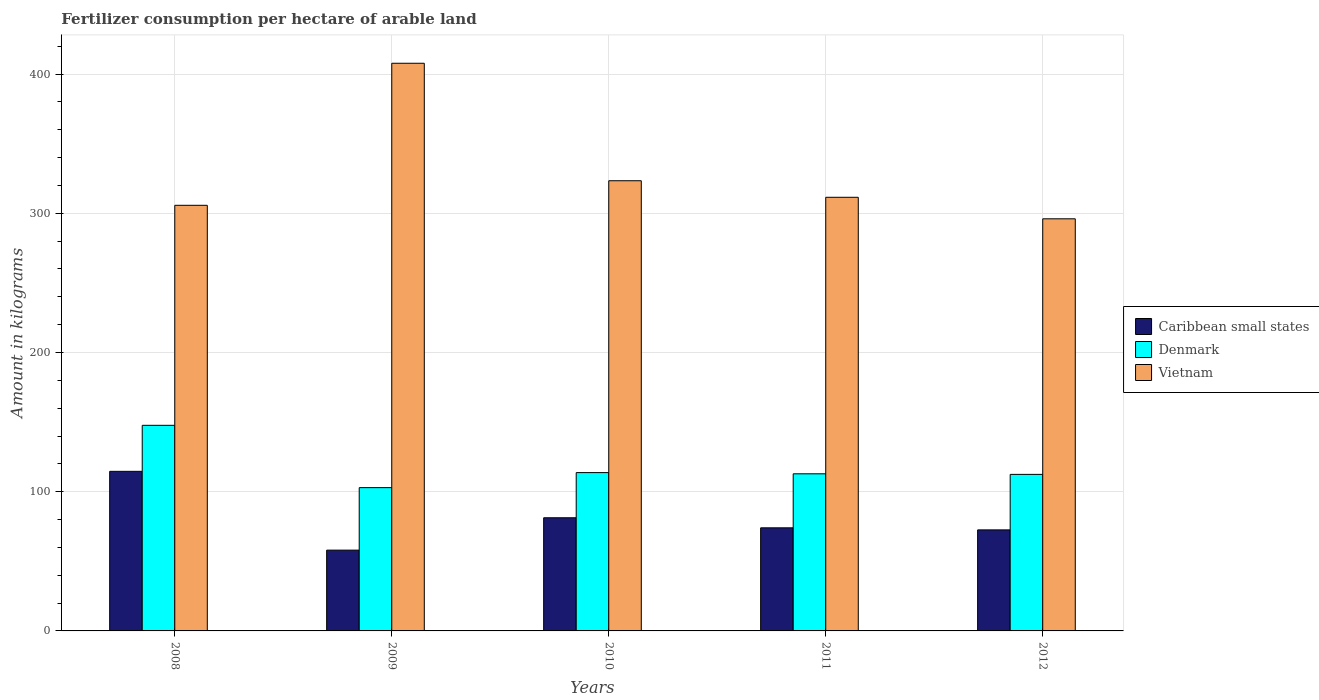Are the number of bars per tick equal to the number of legend labels?
Your response must be concise. Yes. Are the number of bars on each tick of the X-axis equal?
Provide a succinct answer. Yes. How many bars are there on the 1st tick from the left?
Give a very brief answer. 3. How many bars are there on the 3rd tick from the right?
Your answer should be compact. 3. In how many cases, is the number of bars for a given year not equal to the number of legend labels?
Provide a short and direct response. 0. What is the amount of fertilizer consumption in Denmark in 2009?
Provide a succinct answer. 102.92. Across all years, what is the maximum amount of fertilizer consumption in Vietnam?
Keep it short and to the point. 407.72. Across all years, what is the minimum amount of fertilizer consumption in Denmark?
Ensure brevity in your answer.  102.92. In which year was the amount of fertilizer consumption in Vietnam minimum?
Your answer should be very brief. 2012. What is the total amount of fertilizer consumption in Denmark in the graph?
Give a very brief answer. 589.59. What is the difference between the amount of fertilizer consumption in Caribbean small states in 2011 and that in 2012?
Provide a succinct answer. 1.49. What is the difference between the amount of fertilizer consumption in Vietnam in 2008 and the amount of fertilizer consumption in Caribbean small states in 2010?
Keep it short and to the point. 224.42. What is the average amount of fertilizer consumption in Caribbean small states per year?
Provide a succinct answer. 80.11. In the year 2011, what is the difference between the amount of fertilizer consumption in Denmark and amount of fertilizer consumption in Caribbean small states?
Provide a short and direct response. 38.79. In how many years, is the amount of fertilizer consumption in Caribbean small states greater than 400 kg?
Make the answer very short. 0. What is the ratio of the amount of fertilizer consumption in Denmark in 2009 to that in 2012?
Provide a short and direct response. 0.92. Is the difference between the amount of fertilizer consumption in Denmark in 2009 and 2010 greater than the difference between the amount of fertilizer consumption in Caribbean small states in 2009 and 2010?
Give a very brief answer. Yes. What is the difference between the highest and the second highest amount of fertilizer consumption in Caribbean small states?
Your response must be concise. 33.34. What is the difference between the highest and the lowest amount of fertilizer consumption in Caribbean small states?
Give a very brief answer. 56.59. In how many years, is the amount of fertilizer consumption in Denmark greater than the average amount of fertilizer consumption in Denmark taken over all years?
Make the answer very short. 1. Is the sum of the amount of fertilizer consumption in Denmark in 2008 and 2011 greater than the maximum amount of fertilizer consumption in Vietnam across all years?
Provide a succinct answer. No. Is it the case that in every year, the sum of the amount of fertilizer consumption in Denmark and amount of fertilizer consumption in Caribbean small states is greater than the amount of fertilizer consumption in Vietnam?
Keep it short and to the point. No. Are all the bars in the graph horizontal?
Provide a short and direct response. No. How many years are there in the graph?
Provide a succinct answer. 5. What is the difference between two consecutive major ticks on the Y-axis?
Offer a very short reply. 100. Are the values on the major ticks of Y-axis written in scientific E-notation?
Keep it short and to the point. No. Does the graph contain any zero values?
Your answer should be very brief. No. Does the graph contain grids?
Provide a short and direct response. Yes. Where does the legend appear in the graph?
Keep it short and to the point. Center right. How are the legend labels stacked?
Give a very brief answer. Vertical. What is the title of the graph?
Your answer should be compact. Fertilizer consumption per hectare of arable land. What is the label or title of the X-axis?
Keep it short and to the point. Years. What is the label or title of the Y-axis?
Offer a very short reply. Amount in kilograms. What is the Amount in kilograms in Caribbean small states in 2008?
Keep it short and to the point. 114.62. What is the Amount in kilograms in Denmark in 2008?
Ensure brevity in your answer.  147.68. What is the Amount in kilograms in Vietnam in 2008?
Your answer should be very brief. 305.7. What is the Amount in kilograms of Caribbean small states in 2009?
Your answer should be very brief. 58.03. What is the Amount in kilograms in Denmark in 2009?
Offer a very short reply. 102.92. What is the Amount in kilograms of Vietnam in 2009?
Your response must be concise. 407.72. What is the Amount in kilograms of Caribbean small states in 2010?
Make the answer very short. 81.27. What is the Amount in kilograms of Denmark in 2010?
Your answer should be very brief. 113.71. What is the Amount in kilograms in Vietnam in 2010?
Provide a succinct answer. 323.34. What is the Amount in kilograms of Caribbean small states in 2011?
Provide a succinct answer. 74.06. What is the Amount in kilograms in Denmark in 2011?
Offer a very short reply. 112.85. What is the Amount in kilograms of Vietnam in 2011?
Offer a terse response. 311.46. What is the Amount in kilograms of Caribbean small states in 2012?
Provide a short and direct response. 72.57. What is the Amount in kilograms in Denmark in 2012?
Your answer should be compact. 112.43. What is the Amount in kilograms of Vietnam in 2012?
Make the answer very short. 296. Across all years, what is the maximum Amount in kilograms of Caribbean small states?
Give a very brief answer. 114.62. Across all years, what is the maximum Amount in kilograms of Denmark?
Keep it short and to the point. 147.68. Across all years, what is the maximum Amount in kilograms in Vietnam?
Provide a succinct answer. 407.72. Across all years, what is the minimum Amount in kilograms of Caribbean small states?
Your answer should be compact. 58.03. Across all years, what is the minimum Amount in kilograms in Denmark?
Offer a terse response. 102.92. Across all years, what is the minimum Amount in kilograms in Vietnam?
Provide a succinct answer. 296. What is the total Amount in kilograms in Caribbean small states in the graph?
Your response must be concise. 400.54. What is the total Amount in kilograms in Denmark in the graph?
Keep it short and to the point. 589.59. What is the total Amount in kilograms of Vietnam in the graph?
Keep it short and to the point. 1644.21. What is the difference between the Amount in kilograms in Caribbean small states in 2008 and that in 2009?
Make the answer very short. 56.59. What is the difference between the Amount in kilograms of Denmark in 2008 and that in 2009?
Your response must be concise. 44.76. What is the difference between the Amount in kilograms in Vietnam in 2008 and that in 2009?
Your response must be concise. -102.02. What is the difference between the Amount in kilograms of Caribbean small states in 2008 and that in 2010?
Give a very brief answer. 33.34. What is the difference between the Amount in kilograms of Denmark in 2008 and that in 2010?
Your answer should be compact. 33.96. What is the difference between the Amount in kilograms of Vietnam in 2008 and that in 2010?
Your answer should be compact. -17.64. What is the difference between the Amount in kilograms of Caribbean small states in 2008 and that in 2011?
Keep it short and to the point. 40.56. What is the difference between the Amount in kilograms in Denmark in 2008 and that in 2011?
Your answer should be compact. 34.83. What is the difference between the Amount in kilograms of Vietnam in 2008 and that in 2011?
Provide a succinct answer. -5.76. What is the difference between the Amount in kilograms of Caribbean small states in 2008 and that in 2012?
Your response must be concise. 42.05. What is the difference between the Amount in kilograms in Denmark in 2008 and that in 2012?
Your answer should be very brief. 35.24. What is the difference between the Amount in kilograms in Vietnam in 2008 and that in 2012?
Keep it short and to the point. 9.7. What is the difference between the Amount in kilograms in Caribbean small states in 2009 and that in 2010?
Offer a terse response. -23.25. What is the difference between the Amount in kilograms of Denmark in 2009 and that in 2010?
Your answer should be very brief. -10.79. What is the difference between the Amount in kilograms in Vietnam in 2009 and that in 2010?
Offer a very short reply. 84.38. What is the difference between the Amount in kilograms of Caribbean small states in 2009 and that in 2011?
Provide a short and direct response. -16.03. What is the difference between the Amount in kilograms in Denmark in 2009 and that in 2011?
Your answer should be compact. -9.93. What is the difference between the Amount in kilograms in Vietnam in 2009 and that in 2011?
Offer a terse response. 96.26. What is the difference between the Amount in kilograms of Caribbean small states in 2009 and that in 2012?
Keep it short and to the point. -14.54. What is the difference between the Amount in kilograms in Denmark in 2009 and that in 2012?
Offer a terse response. -9.51. What is the difference between the Amount in kilograms of Vietnam in 2009 and that in 2012?
Your answer should be very brief. 111.72. What is the difference between the Amount in kilograms of Caribbean small states in 2010 and that in 2011?
Provide a succinct answer. 7.22. What is the difference between the Amount in kilograms in Denmark in 2010 and that in 2011?
Give a very brief answer. 0.86. What is the difference between the Amount in kilograms of Vietnam in 2010 and that in 2011?
Offer a very short reply. 11.88. What is the difference between the Amount in kilograms of Caribbean small states in 2010 and that in 2012?
Ensure brevity in your answer.  8.71. What is the difference between the Amount in kilograms in Denmark in 2010 and that in 2012?
Ensure brevity in your answer.  1.28. What is the difference between the Amount in kilograms of Vietnam in 2010 and that in 2012?
Make the answer very short. 27.34. What is the difference between the Amount in kilograms in Caribbean small states in 2011 and that in 2012?
Provide a succinct answer. 1.49. What is the difference between the Amount in kilograms in Denmark in 2011 and that in 2012?
Your answer should be very brief. 0.42. What is the difference between the Amount in kilograms in Vietnam in 2011 and that in 2012?
Give a very brief answer. 15.46. What is the difference between the Amount in kilograms of Caribbean small states in 2008 and the Amount in kilograms of Denmark in 2009?
Your answer should be compact. 11.7. What is the difference between the Amount in kilograms of Caribbean small states in 2008 and the Amount in kilograms of Vietnam in 2009?
Ensure brevity in your answer.  -293.1. What is the difference between the Amount in kilograms in Denmark in 2008 and the Amount in kilograms in Vietnam in 2009?
Your answer should be compact. -260.04. What is the difference between the Amount in kilograms of Caribbean small states in 2008 and the Amount in kilograms of Denmark in 2010?
Offer a very short reply. 0.91. What is the difference between the Amount in kilograms in Caribbean small states in 2008 and the Amount in kilograms in Vietnam in 2010?
Give a very brief answer. -208.72. What is the difference between the Amount in kilograms of Denmark in 2008 and the Amount in kilograms of Vietnam in 2010?
Offer a terse response. -175.66. What is the difference between the Amount in kilograms in Caribbean small states in 2008 and the Amount in kilograms in Denmark in 2011?
Provide a succinct answer. 1.77. What is the difference between the Amount in kilograms of Caribbean small states in 2008 and the Amount in kilograms of Vietnam in 2011?
Your response must be concise. -196.84. What is the difference between the Amount in kilograms of Denmark in 2008 and the Amount in kilograms of Vietnam in 2011?
Offer a very short reply. -163.78. What is the difference between the Amount in kilograms of Caribbean small states in 2008 and the Amount in kilograms of Denmark in 2012?
Offer a very short reply. 2.19. What is the difference between the Amount in kilograms of Caribbean small states in 2008 and the Amount in kilograms of Vietnam in 2012?
Your answer should be very brief. -181.38. What is the difference between the Amount in kilograms in Denmark in 2008 and the Amount in kilograms in Vietnam in 2012?
Keep it short and to the point. -148.32. What is the difference between the Amount in kilograms of Caribbean small states in 2009 and the Amount in kilograms of Denmark in 2010?
Provide a short and direct response. -55.68. What is the difference between the Amount in kilograms of Caribbean small states in 2009 and the Amount in kilograms of Vietnam in 2010?
Provide a succinct answer. -265.31. What is the difference between the Amount in kilograms in Denmark in 2009 and the Amount in kilograms in Vietnam in 2010?
Provide a succinct answer. -220.42. What is the difference between the Amount in kilograms in Caribbean small states in 2009 and the Amount in kilograms in Denmark in 2011?
Ensure brevity in your answer.  -54.82. What is the difference between the Amount in kilograms in Caribbean small states in 2009 and the Amount in kilograms in Vietnam in 2011?
Offer a very short reply. -253.43. What is the difference between the Amount in kilograms of Denmark in 2009 and the Amount in kilograms of Vietnam in 2011?
Offer a terse response. -208.54. What is the difference between the Amount in kilograms of Caribbean small states in 2009 and the Amount in kilograms of Denmark in 2012?
Provide a short and direct response. -54.4. What is the difference between the Amount in kilograms in Caribbean small states in 2009 and the Amount in kilograms in Vietnam in 2012?
Ensure brevity in your answer.  -237.97. What is the difference between the Amount in kilograms in Denmark in 2009 and the Amount in kilograms in Vietnam in 2012?
Your answer should be very brief. -193.08. What is the difference between the Amount in kilograms of Caribbean small states in 2010 and the Amount in kilograms of Denmark in 2011?
Provide a short and direct response. -31.57. What is the difference between the Amount in kilograms in Caribbean small states in 2010 and the Amount in kilograms in Vietnam in 2011?
Make the answer very short. -230.18. What is the difference between the Amount in kilograms in Denmark in 2010 and the Amount in kilograms in Vietnam in 2011?
Offer a very short reply. -197.74. What is the difference between the Amount in kilograms of Caribbean small states in 2010 and the Amount in kilograms of Denmark in 2012?
Make the answer very short. -31.16. What is the difference between the Amount in kilograms of Caribbean small states in 2010 and the Amount in kilograms of Vietnam in 2012?
Your answer should be compact. -214.72. What is the difference between the Amount in kilograms in Denmark in 2010 and the Amount in kilograms in Vietnam in 2012?
Your answer should be very brief. -182.28. What is the difference between the Amount in kilograms in Caribbean small states in 2011 and the Amount in kilograms in Denmark in 2012?
Ensure brevity in your answer.  -38.38. What is the difference between the Amount in kilograms in Caribbean small states in 2011 and the Amount in kilograms in Vietnam in 2012?
Your answer should be very brief. -221.94. What is the difference between the Amount in kilograms of Denmark in 2011 and the Amount in kilograms of Vietnam in 2012?
Provide a succinct answer. -183.15. What is the average Amount in kilograms of Caribbean small states per year?
Give a very brief answer. 80.11. What is the average Amount in kilograms of Denmark per year?
Offer a very short reply. 117.92. What is the average Amount in kilograms of Vietnam per year?
Your answer should be compact. 328.84. In the year 2008, what is the difference between the Amount in kilograms of Caribbean small states and Amount in kilograms of Denmark?
Provide a succinct answer. -33.06. In the year 2008, what is the difference between the Amount in kilograms of Caribbean small states and Amount in kilograms of Vietnam?
Your response must be concise. -191.08. In the year 2008, what is the difference between the Amount in kilograms of Denmark and Amount in kilograms of Vietnam?
Offer a terse response. -158.02. In the year 2009, what is the difference between the Amount in kilograms of Caribbean small states and Amount in kilograms of Denmark?
Make the answer very short. -44.89. In the year 2009, what is the difference between the Amount in kilograms of Caribbean small states and Amount in kilograms of Vietnam?
Your answer should be compact. -349.69. In the year 2009, what is the difference between the Amount in kilograms in Denmark and Amount in kilograms in Vietnam?
Your answer should be compact. -304.8. In the year 2010, what is the difference between the Amount in kilograms of Caribbean small states and Amount in kilograms of Denmark?
Offer a very short reply. -32.44. In the year 2010, what is the difference between the Amount in kilograms in Caribbean small states and Amount in kilograms in Vietnam?
Give a very brief answer. -242.07. In the year 2010, what is the difference between the Amount in kilograms of Denmark and Amount in kilograms of Vietnam?
Your answer should be very brief. -209.63. In the year 2011, what is the difference between the Amount in kilograms in Caribbean small states and Amount in kilograms in Denmark?
Keep it short and to the point. -38.79. In the year 2011, what is the difference between the Amount in kilograms of Caribbean small states and Amount in kilograms of Vietnam?
Offer a very short reply. -237.4. In the year 2011, what is the difference between the Amount in kilograms of Denmark and Amount in kilograms of Vietnam?
Provide a short and direct response. -198.61. In the year 2012, what is the difference between the Amount in kilograms of Caribbean small states and Amount in kilograms of Denmark?
Provide a succinct answer. -39.87. In the year 2012, what is the difference between the Amount in kilograms of Caribbean small states and Amount in kilograms of Vietnam?
Your answer should be compact. -223.43. In the year 2012, what is the difference between the Amount in kilograms in Denmark and Amount in kilograms in Vietnam?
Offer a terse response. -183.56. What is the ratio of the Amount in kilograms of Caribbean small states in 2008 to that in 2009?
Offer a terse response. 1.98. What is the ratio of the Amount in kilograms in Denmark in 2008 to that in 2009?
Ensure brevity in your answer.  1.43. What is the ratio of the Amount in kilograms of Vietnam in 2008 to that in 2009?
Offer a terse response. 0.75. What is the ratio of the Amount in kilograms of Caribbean small states in 2008 to that in 2010?
Your response must be concise. 1.41. What is the ratio of the Amount in kilograms of Denmark in 2008 to that in 2010?
Provide a short and direct response. 1.3. What is the ratio of the Amount in kilograms of Vietnam in 2008 to that in 2010?
Your answer should be compact. 0.95. What is the ratio of the Amount in kilograms of Caribbean small states in 2008 to that in 2011?
Provide a short and direct response. 1.55. What is the ratio of the Amount in kilograms in Denmark in 2008 to that in 2011?
Your answer should be very brief. 1.31. What is the ratio of the Amount in kilograms of Vietnam in 2008 to that in 2011?
Offer a terse response. 0.98. What is the ratio of the Amount in kilograms of Caribbean small states in 2008 to that in 2012?
Make the answer very short. 1.58. What is the ratio of the Amount in kilograms in Denmark in 2008 to that in 2012?
Your answer should be compact. 1.31. What is the ratio of the Amount in kilograms in Vietnam in 2008 to that in 2012?
Ensure brevity in your answer.  1.03. What is the ratio of the Amount in kilograms of Caribbean small states in 2009 to that in 2010?
Provide a succinct answer. 0.71. What is the ratio of the Amount in kilograms of Denmark in 2009 to that in 2010?
Offer a terse response. 0.91. What is the ratio of the Amount in kilograms of Vietnam in 2009 to that in 2010?
Give a very brief answer. 1.26. What is the ratio of the Amount in kilograms of Caribbean small states in 2009 to that in 2011?
Your answer should be compact. 0.78. What is the ratio of the Amount in kilograms in Denmark in 2009 to that in 2011?
Offer a terse response. 0.91. What is the ratio of the Amount in kilograms in Vietnam in 2009 to that in 2011?
Ensure brevity in your answer.  1.31. What is the ratio of the Amount in kilograms in Caribbean small states in 2009 to that in 2012?
Ensure brevity in your answer.  0.8. What is the ratio of the Amount in kilograms in Denmark in 2009 to that in 2012?
Your response must be concise. 0.92. What is the ratio of the Amount in kilograms of Vietnam in 2009 to that in 2012?
Your answer should be compact. 1.38. What is the ratio of the Amount in kilograms of Caribbean small states in 2010 to that in 2011?
Give a very brief answer. 1.1. What is the ratio of the Amount in kilograms in Denmark in 2010 to that in 2011?
Give a very brief answer. 1.01. What is the ratio of the Amount in kilograms in Vietnam in 2010 to that in 2011?
Offer a very short reply. 1.04. What is the ratio of the Amount in kilograms in Caribbean small states in 2010 to that in 2012?
Ensure brevity in your answer.  1.12. What is the ratio of the Amount in kilograms of Denmark in 2010 to that in 2012?
Make the answer very short. 1.01. What is the ratio of the Amount in kilograms in Vietnam in 2010 to that in 2012?
Make the answer very short. 1.09. What is the ratio of the Amount in kilograms of Caribbean small states in 2011 to that in 2012?
Offer a very short reply. 1.02. What is the ratio of the Amount in kilograms of Vietnam in 2011 to that in 2012?
Give a very brief answer. 1.05. What is the difference between the highest and the second highest Amount in kilograms of Caribbean small states?
Your response must be concise. 33.34. What is the difference between the highest and the second highest Amount in kilograms of Denmark?
Your answer should be very brief. 33.96. What is the difference between the highest and the second highest Amount in kilograms in Vietnam?
Offer a terse response. 84.38. What is the difference between the highest and the lowest Amount in kilograms of Caribbean small states?
Offer a very short reply. 56.59. What is the difference between the highest and the lowest Amount in kilograms in Denmark?
Offer a very short reply. 44.76. What is the difference between the highest and the lowest Amount in kilograms in Vietnam?
Your answer should be very brief. 111.72. 